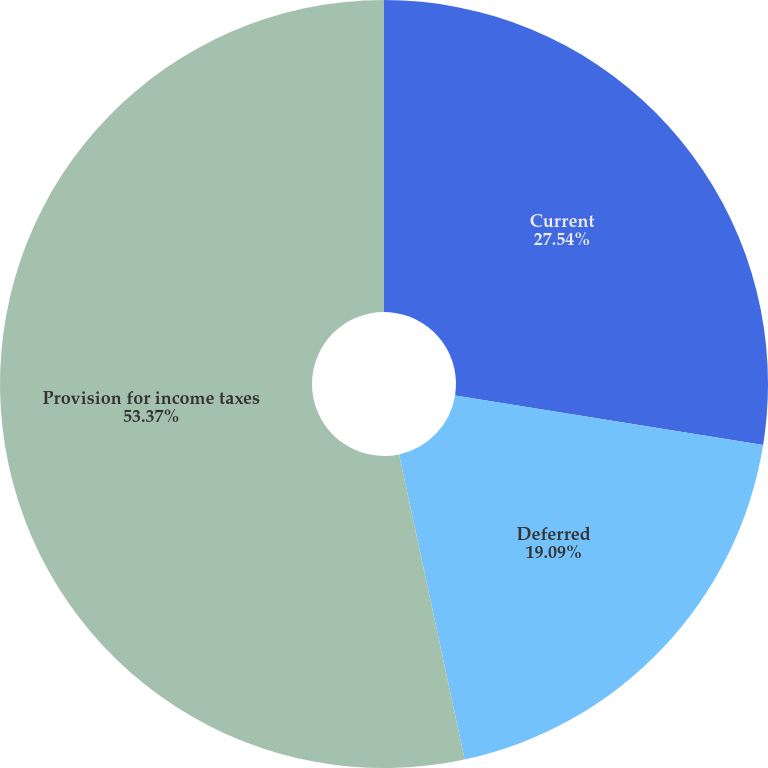Convert chart to OTSL. <chart><loc_0><loc_0><loc_500><loc_500><pie_chart><fcel>Current<fcel>Deferred<fcel>Provision for income taxes<nl><fcel>27.54%<fcel>19.09%<fcel>53.37%<nl></chart> 